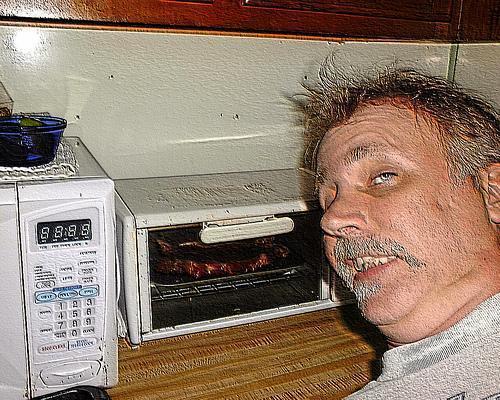Does the caption "The person is facing away from the oven." correctly depict the image?
Answer yes or no. Yes. 